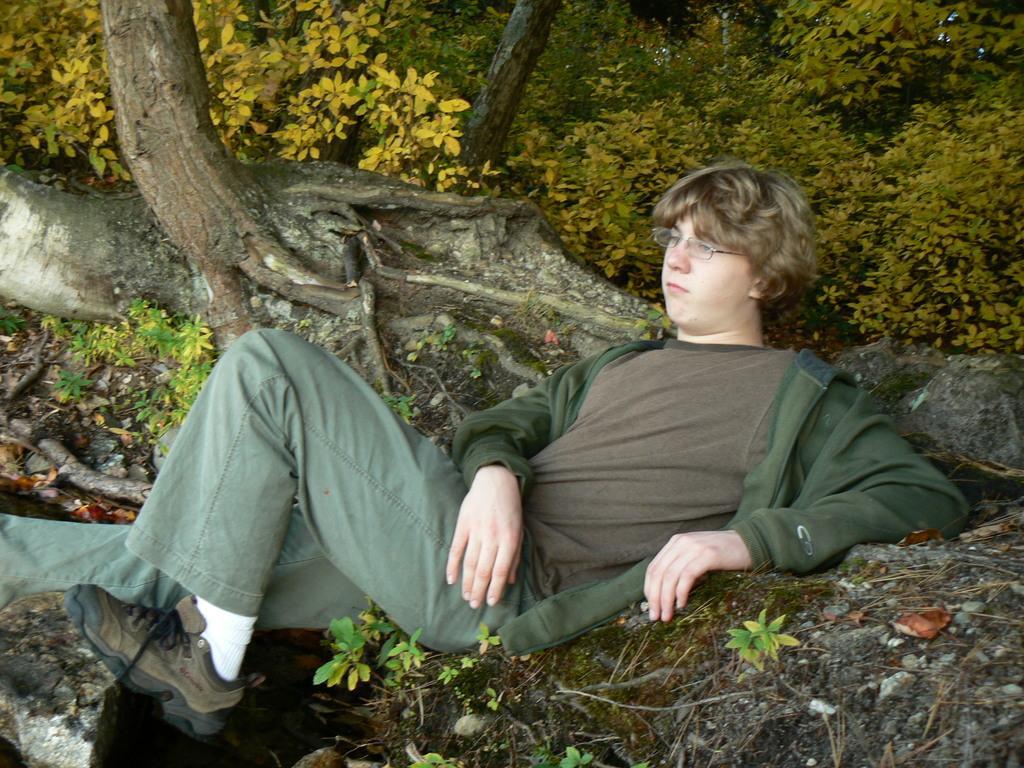In one or two sentences, can you explain what this image depicts? In this image we can see a person wearing specs is lying on the ground. In the background there are trees. 